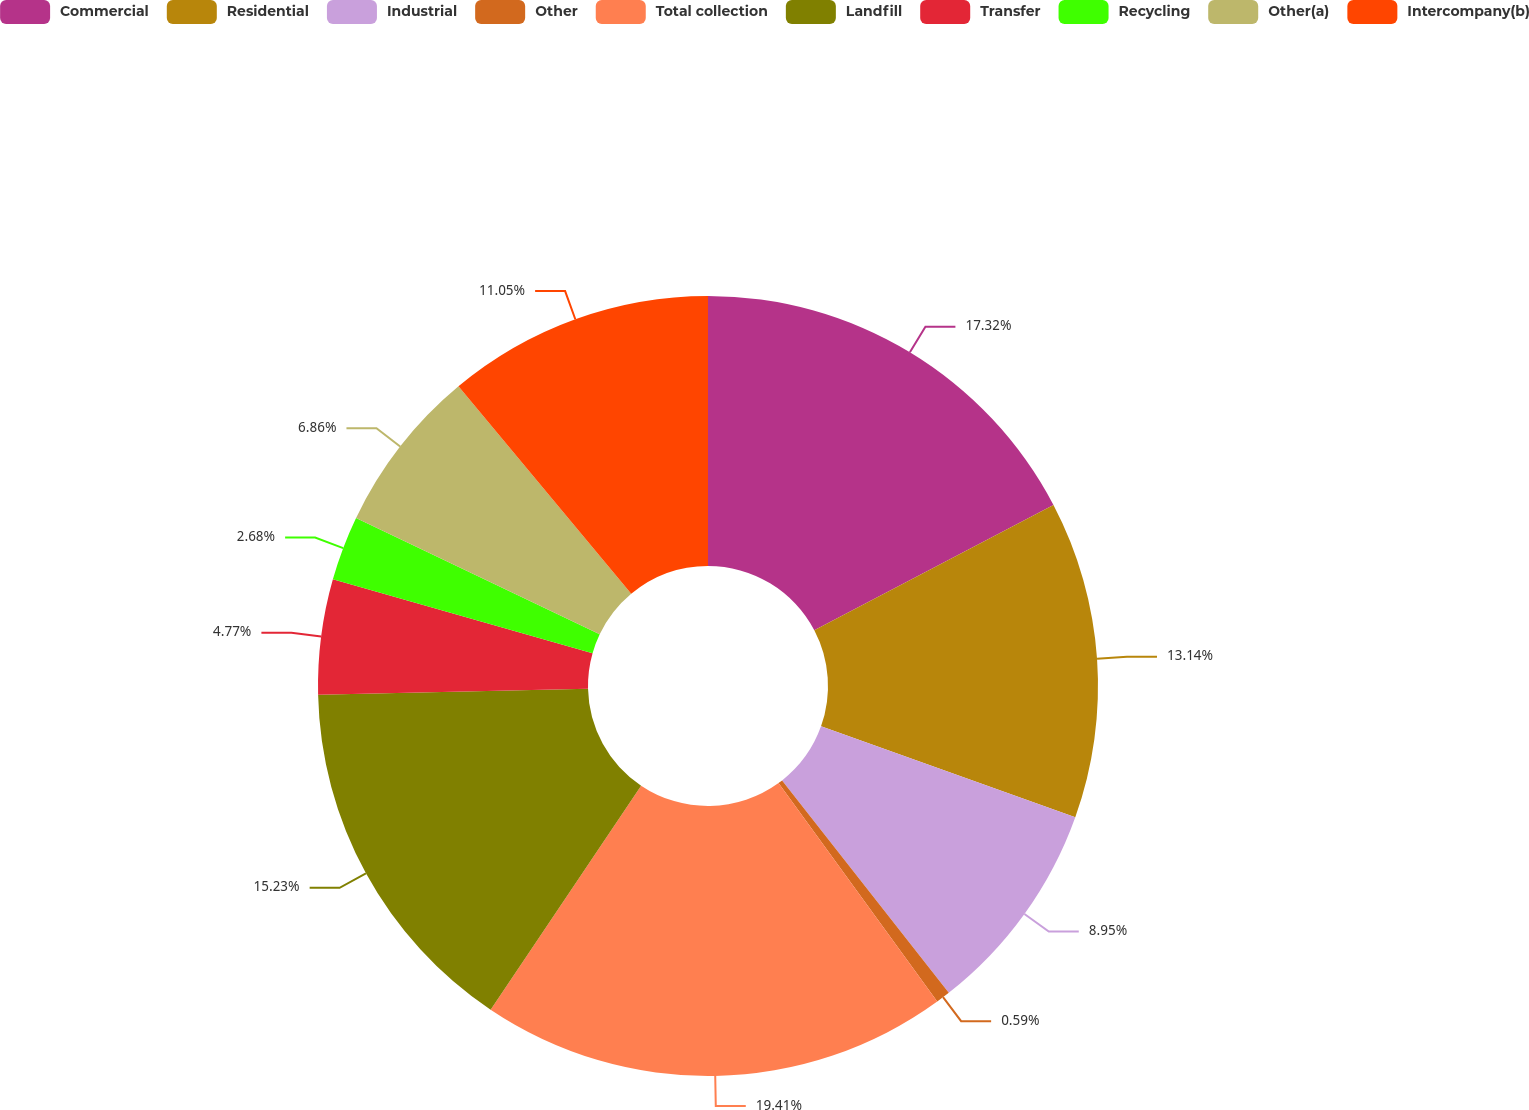Convert chart to OTSL. <chart><loc_0><loc_0><loc_500><loc_500><pie_chart><fcel>Commercial<fcel>Residential<fcel>Industrial<fcel>Other<fcel>Total collection<fcel>Landfill<fcel>Transfer<fcel>Recycling<fcel>Other(a)<fcel>Intercompany(b)<nl><fcel>17.32%<fcel>13.14%<fcel>8.95%<fcel>0.59%<fcel>19.41%<fcel>15.23%<fcel>4.77%<fcel>2.68%<fcel>6.86%<fcel>11.05%<nl></chart> 